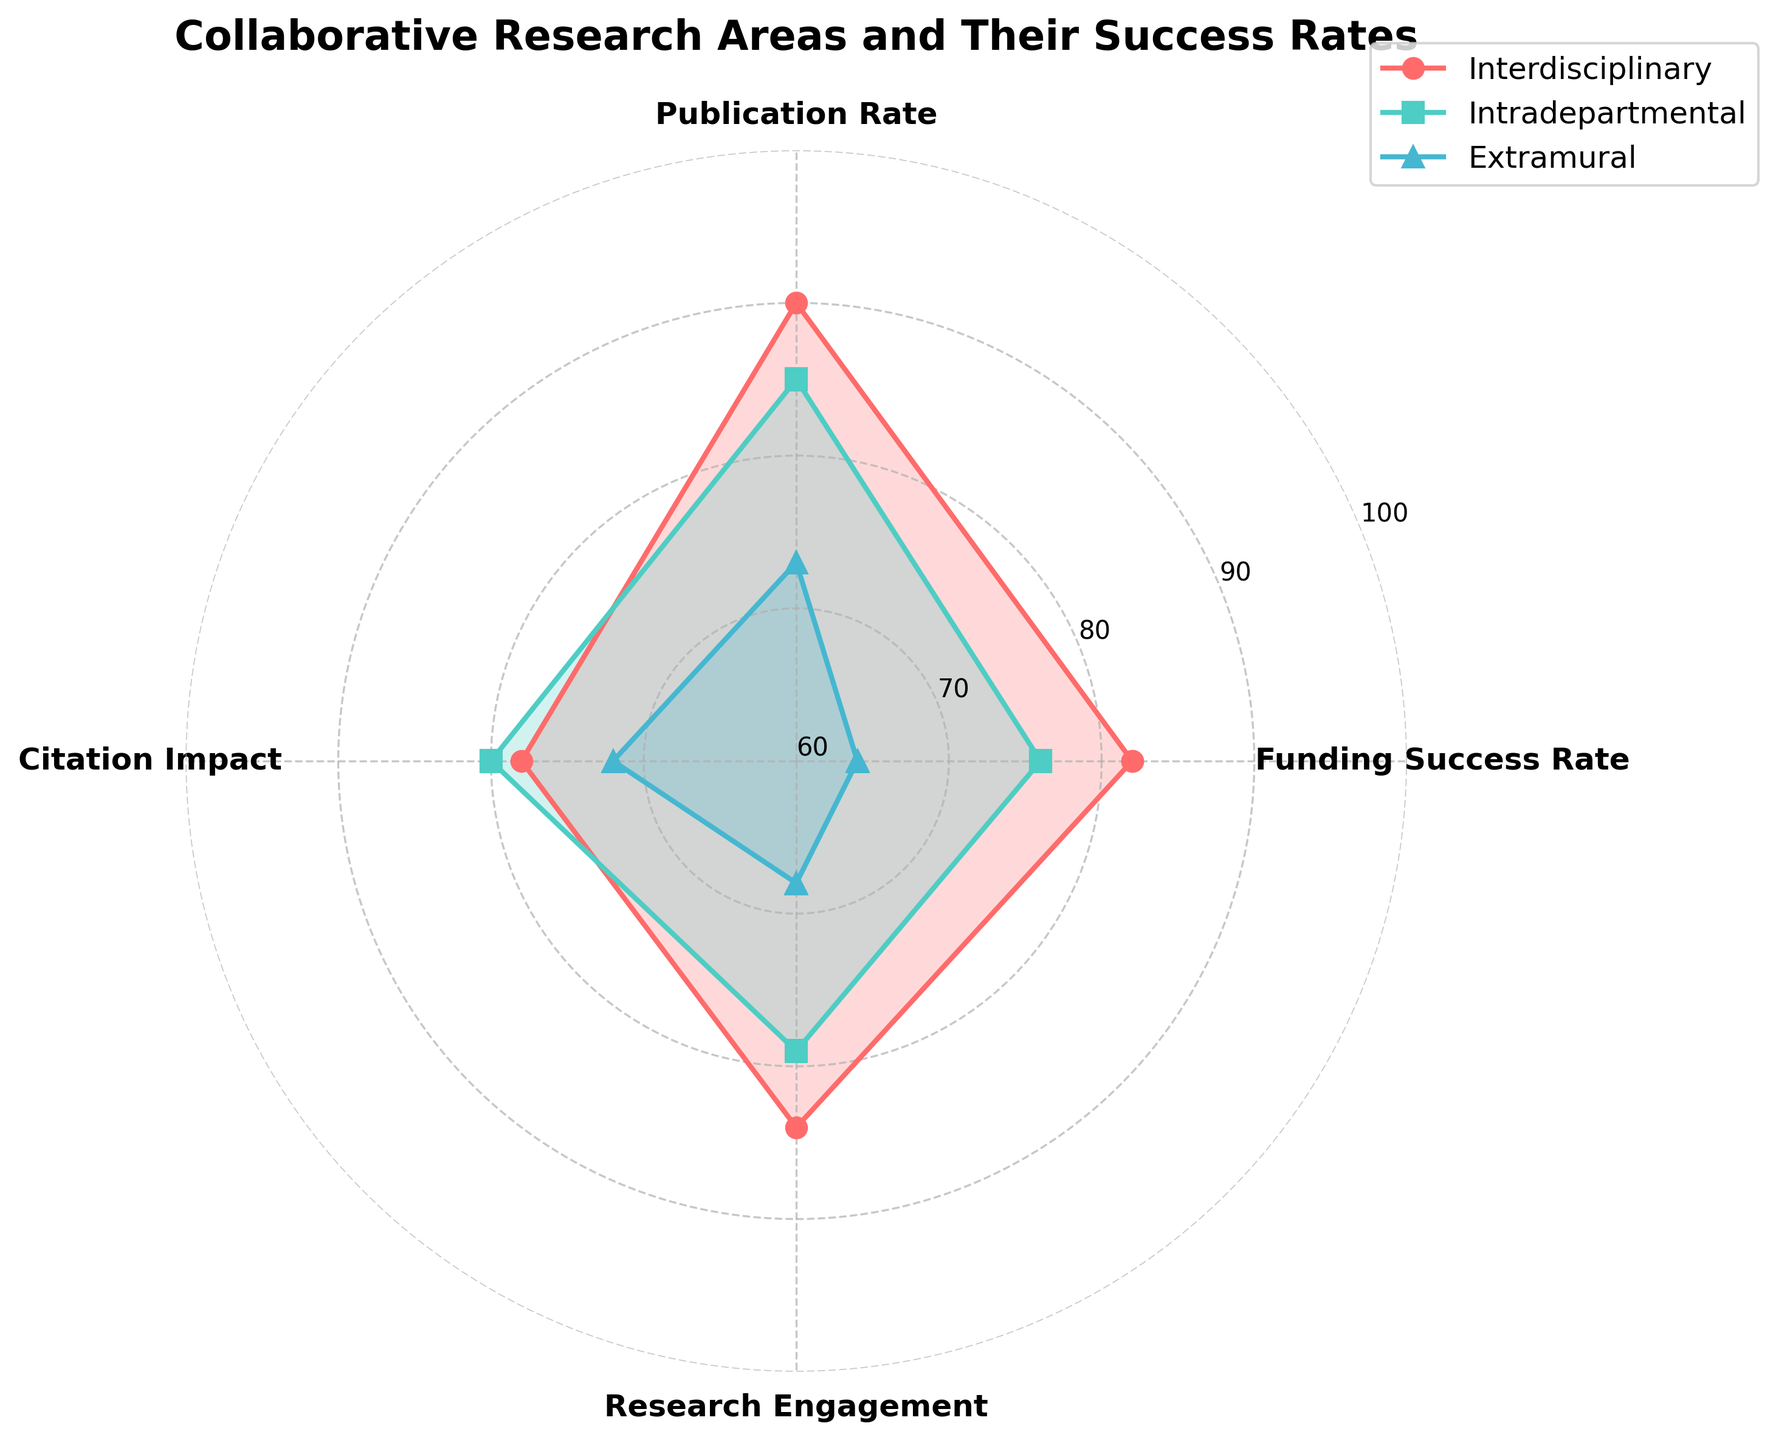What are the four categories listed on the radar chart? The radar chart has four main categories listed around its perimeter. They are Funding Success Rate, Publication Rate, Citation Impact, and Research Engagement.
Answer: Funding Success Rate, Publication Rate, Citation Impact, Research Engagement Which group has the highest Publication Rate? By examining the axis labels and data points for Publication Rate, the highest value is in the Interdisciplinary group with a rate of 90.
Answer: Interdisciplinary What's the difference in Citation Impact between the Intradepartmental and Extramural groups? Look at the Citation Impact values for Intradepartmental (80) and Extramural (72). The difference can be calculated as 80 - 72 = 8.
Answer: 8 Which category shows the lowest success rate across all groups? By observing the radar chart, the category with the lowest value in any group is the Extramural group's Research Engagement with a value of 68.
Answer: Research Engagement Compare the Funding Success Rates of all groups. Which one is the highest and which one is the lowest? Looking at the Funding Success Rates, the Interdisciplinary group has the highest rate at 82, and the Extramural group has the lowest rate at 64.
Answer: Highest: Interdisciplinary, Lowest: Extramural Are there any categories where the Intradepartmental group scores higher than the Interdisciplinary group? By scanning the radar chart, we see that none of the categories have the Intradepartmental group scoring higher than the Interdisciplinary group.
Answer: No Calculate the average success rate for Research Engagement across all groups. To calculate the average, sum the Research Engagement values of all groups (84 + 79 + 68) and divide by the number of groups (3). The calculation is (84+79+68)/3 = 77.
Answer: 77 What is the range of values for Publication Rate across all groups? The Publication Rate ranges from the lowest value of 73 (Extramural) to the highest value of 90 (Interdisciplinary). The range can be calculated as 90 - 73 = 17.
Answer: 17 Which group has more consistent performance across all categories? Consistent performance would be indicated by similar values across all categories. The Intradepartmental group shows values of 76, 85, 80, and 79, which are relatively close to each other compared to other groups.
Answer: Intradepartmental 